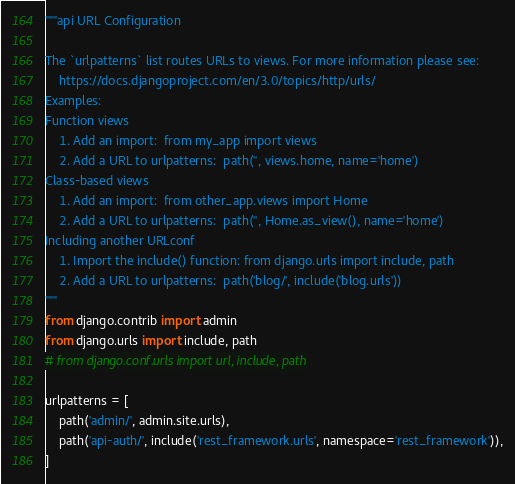Convert code to text. <code><loc_0><loc_0><loc_500><loc_500><_Python_>"""api URL Configuration

The `urlpatterns` list routes URLs to views. For more information please see:
    https://docs.djangoproject.com/en/3.0/topics/http/urls/
Examples:
Function views
    1. Add an import:  from my_app import views
    2. Add a URL to urlpatterns:  path('', views.home, name='home')
Class-based views
    1. Add an import:  from other_app.views import Home
    2. Add a URL to urlpatterns:  path('', Home.as_view(), name='home')
Including another URLconf
    1. Import the include() function: from django.urls import include, path
    2. Add a URL to urlpatterns:  path('blog/', include('blog.urls'))
"""
from django.contrib import admin
from django.urls import include, path
# from django.conf.urls import url, include, path

urlpatterns = [
    path('admin/', admin.site.urls),
    path('api-auth/', include('rest_framework.urls', namespace='rest_framework')),
]
</code> 